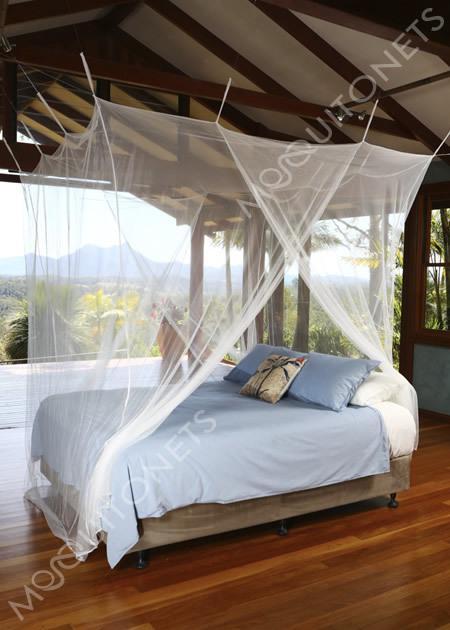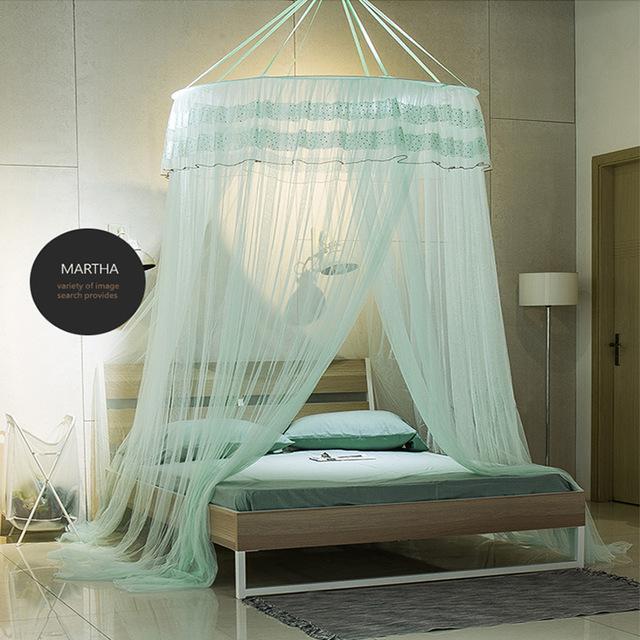The first image is the image on the left, the second image is the image on the right. Assess this claim about the two images: "In the image to the left, the bed canopy is closed.". Correct or not? Answer yes or no. No. 